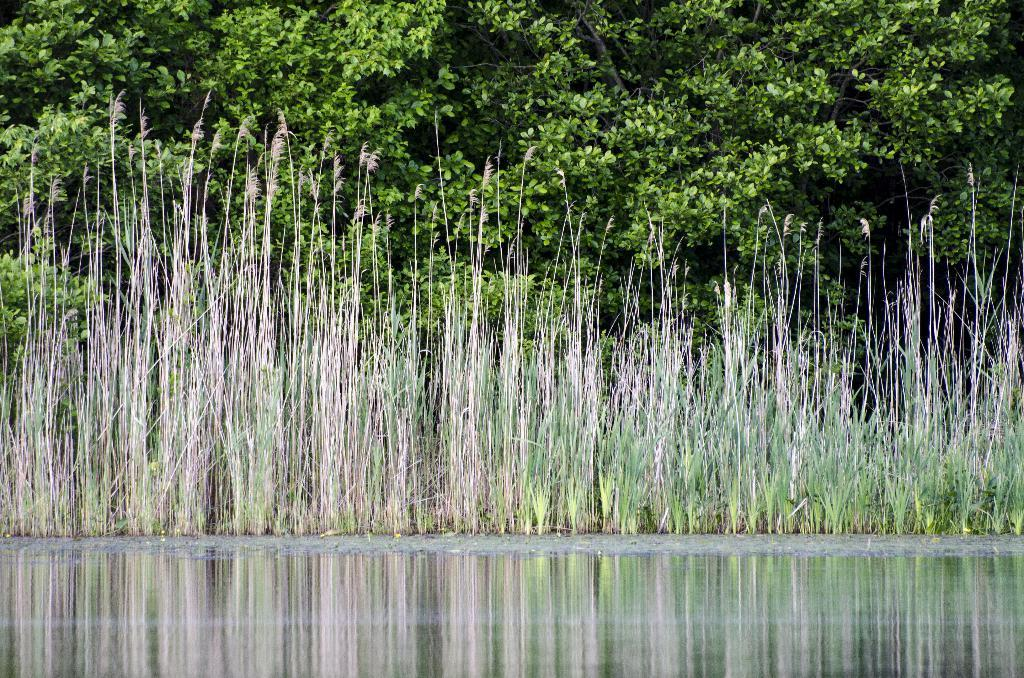What is present at the bottom of the picture? There is water in the bottom of the picture. What is located in the middle of the picture? There is grass in the middle of the picture. What can be seen in the background of the picture? There are trees in the background of the picture. What advice does the aunt give in the picture? There is no aunt present in the picture, so no advice can be given. How many bridges are visible in the picture? There are no bridges visible in the picture; it features water, grass, and trees. 